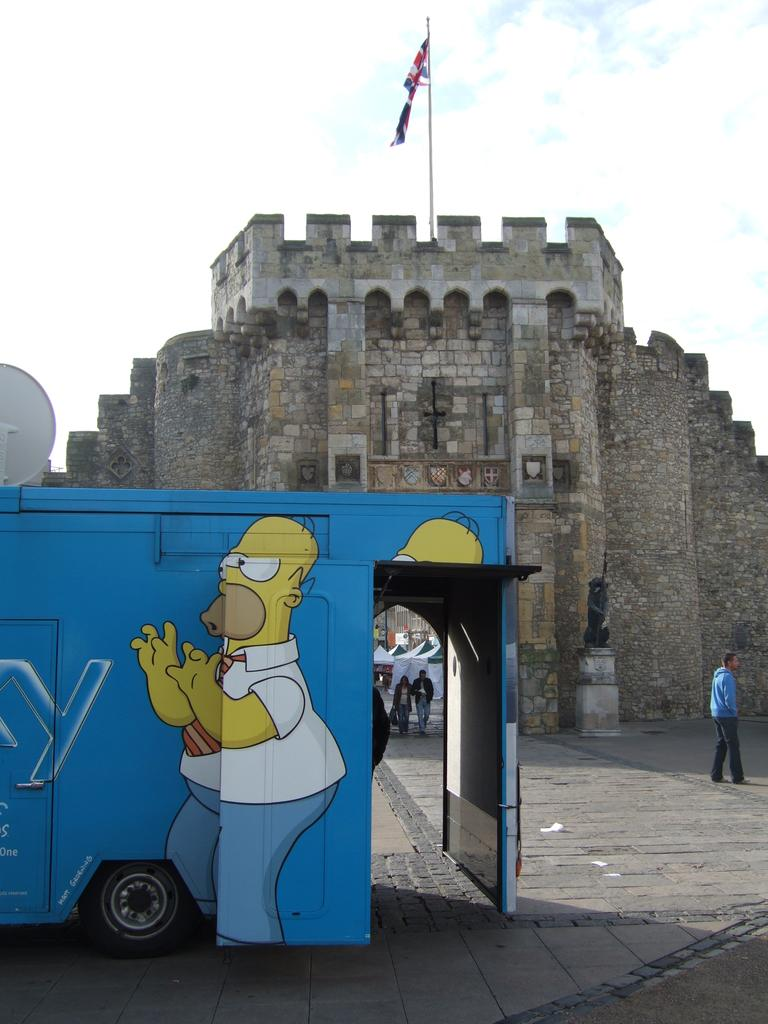What is the main structure in the center of the image? There is a building in the center of the image. What is attached to the building? There is a flag on the building. What can be seen on the left side of the image? There is a bus on the left side of the image. What type of gold material is used to construct the bus in the image? There is no gold material used to construct the bus in the image; it is made of other materials, such as steel or aluminum. 